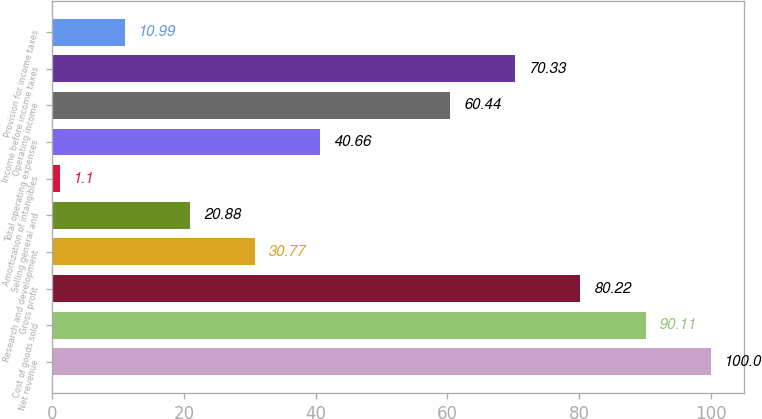Convert chart. <chart><loc_0><loc_0><loc_500><loc_500><bar_chart><fcel>Net revenue<fcel>Cost of goods sold<fcel>Gross profit<fcel>Research and development<fcel>Selling general and<fcel>Amortization of intangibles<fcel>Total operating expenses<fcel>Operating income<fcel>Income before income taxes<fcel>Provision for income taxes<nl><fcel>100<fcel>90.11<fcel>80.22<fcel>30.77<fcel>20.88<fcel>1.1<fcel>40.66<fcel>60.44<fcel>70.33<fcel>10.99<nl></chart> 